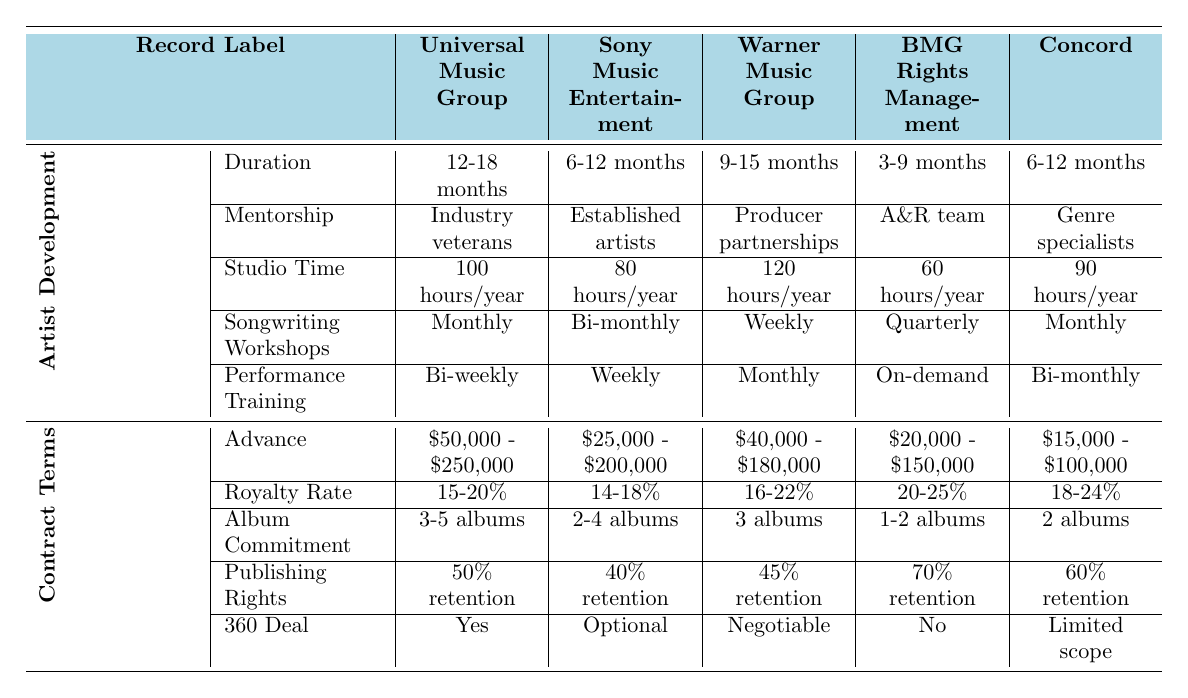What is the duration of the artist development program offered by Universal Music Group? The table indicates that Universal Music Group has an artist development program with a duration of 12-18 months.
Answer: 12-18 months Which record label offers the highest studio time per year for artists? By examining the studio time for each record label, we find Warner Music Group offers 120 hours/year, which is the highest compared to the others.
Answer: 120 hours/year What percentage of royalty does BMG Rights Management offer? According to the table, BMG Rights Management offers a royalty rate ranging from 20% to 25%.
Answer: 20-25% Does Sony Music Entertainment have a 360 deal? The table states that Sony Music Entertainment has an optional 360 deal, confirming that it does indeed have this type of arrangement available.
Answer: Yes What is the average advance amount across all the record labels? To calculate the average advance, we first find the total advance range: (250,000 + 200,000 + 180,000 + 150,000 + 100,000) = 880,000. Dividing by the number of labels (5) gives us an average advance of 176,000.
Answer: $176,000 Which record label requires the longest album commitment by artists? By reviewing the album commitments listed, Universal Music Group has a commitment of 3-5 albums, which is longer than any other label's requirement.
Answer: 3-5 albums How many months does BMG Rights Management's artist development program last at a minimum? The table shows that BMG Rights Management's program lasts a minimum of 3 months based on the range of 3-9 months.
Answer: 3 months Which record label provides bi-weekly performance training? From the data, Universal Music Group offers bi-weekly performance training as part of their artist development program.
Answer: Universal Music Group What is the median publishing rights retention rate across the presented labels? The retention rates (50%, 40%, 45%, 70%, 60%) can be ordered and the median (middle value) is 50%, since when arranged they are 40%, 45%, 50%, 60%, 70%.
Answer: 50% What are the contract terms for the highest royalty rate, and which label offers them? BMG Rights Management offers the highest royalty rate at 20-25%. Therefore, the contract terms are $20,000 - $150,000 advance, 20-25% royalty rate, 1-2 albums commitment, 70% retention, and no 360 deal.
Answer: BMG Rights Management: 20-25% royalty rate Which label has the shortest artist development program duration? According to the table, BMG Rights Management has the shortest program duration, lasting 3-9 months.
Answer: BMG Rights Management 